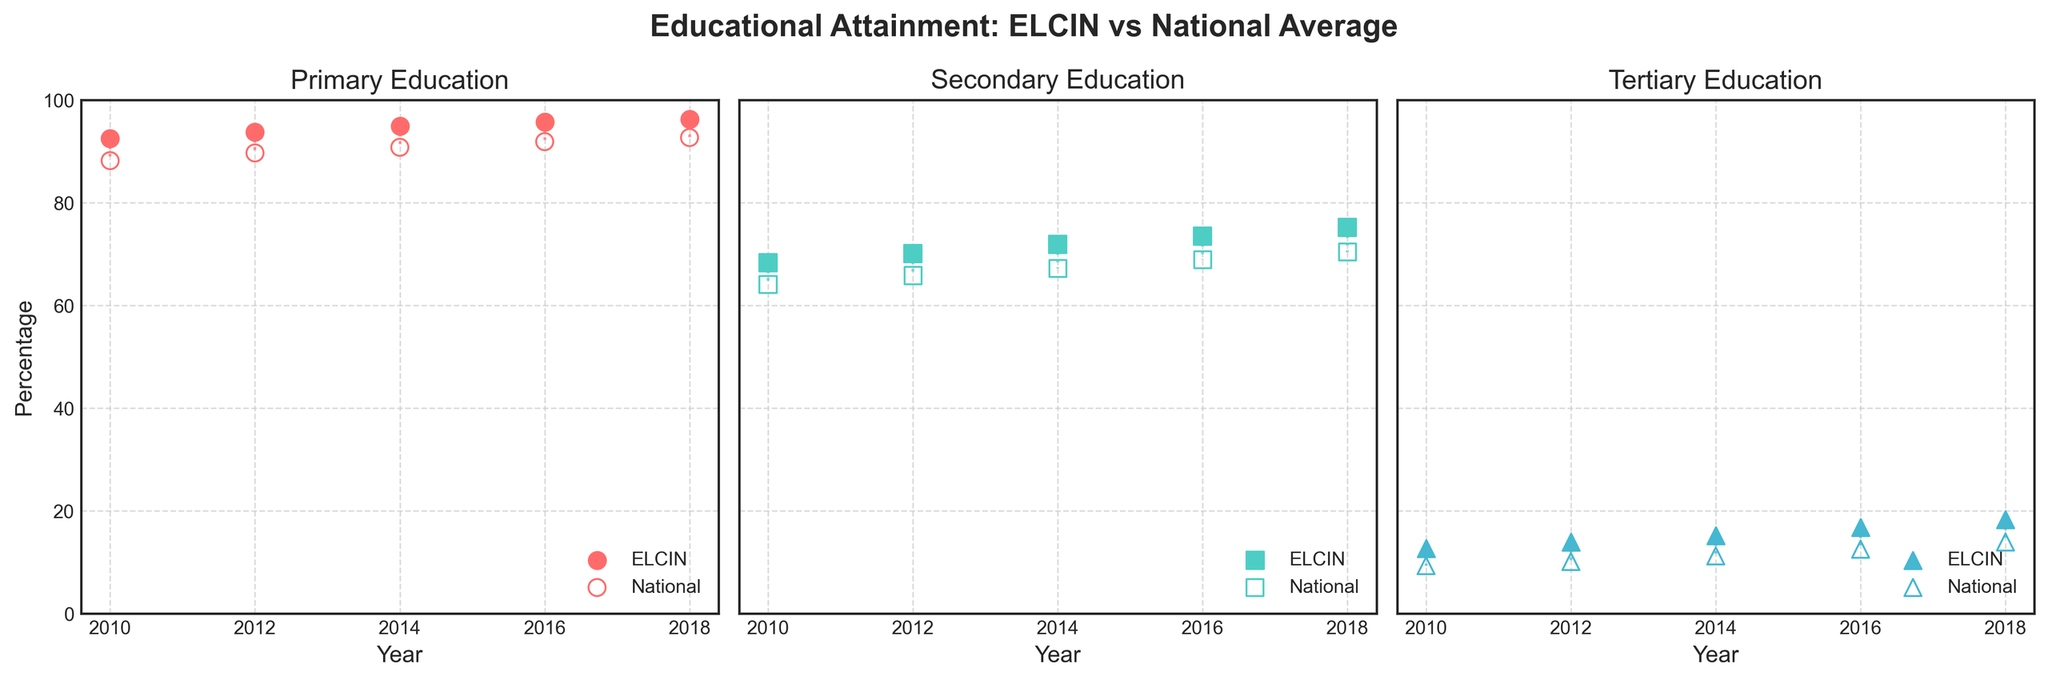What is the title of the plot? The title of the plot is shown at the top and reads "Educational Attainment: ELCIN vs National Average".
Answer: Educational Attainment: ELCIN vs National Average Which years are shown on the x-axis? The x-axis on each subplot displays the years 2010, 2012, 2014, 2016, and 2018.
Answer: 2010, 2012, 2014, 2016, 2018 What is the color used for the markers representing ELCIN data? The markers representing ELCIN data are filled with color: '#FF6B6B' for Primary, '#4ECDC4' for Secondary, and '#45B7D1' for Tertiary levels.
Answer: #FF6B6B, #4ECDC4, #45B7D1 How does the percentage of primary education among ELCIN members change over the years? The percentage of primary education among ELCIN members increases from 92.5% in 2010 to 96.3% in 2018. This can be observed by the upward trend in the figure.
Answer: It increases from 92.5% to 96.3% What is the highest percentage shown for national secondary education in the figure? The highest percentage shown for national secondary education is in 2018, where it reaches 70.4%.
Answer: 70.4% Compare the trends of tertiary education between ELCIN members and the national average. The trends of tertiary education show an upward trajectory for both ELCIN members and the national average. However, ELCIN members start at 12.7% in 2010 and reach 18.3% in 2018, whereas the national average starts lower at 9.3% in 2010 and reaches 13.9% in 2018. ELCIN consistently maintains higher percentages than the national average throughout the period.
Answer: ELCIN consistently higher, both increase Which education level shows the smallest gap between ELCIN members and the national average? By looking at the parallel lines connecting ELCIN and national data points, the smallest gap is seen in primary education, especially in more recent years.
Answer: Primary education In which year did ELCIN have the smallest percentage advantage over the national average in secondary education? By comparing the differences for each year visually, the smallest percentage advantage for ELCIN over the national average in secondary education appears to be in the year 2010.
Answer: 2010 Is the growth rate of tertiary education higher in ELCIN members or the national average? To determine this, compare the initial and final values over the period. For ELCIN, the percentage increased from 12.7% in 2010 to 18.3% in 2018, while for the national average, it increased from 9.3% in 2010 to 13.9% in 2018. The absolute increase is higher in ELCIN (5.6%) compared to the national average (4.6%).
Answer: Higher in ELCIN Between 2010 and 2018, which year shows the largest increase in tertiary education for ELCIN members? By identifying the yearly data points for ELCIN tertiary education, the largest year-over-year increase can be seen between 2016 (16.8%) and 2018 (18.3%).
Answer: Between 2016 and 2018 